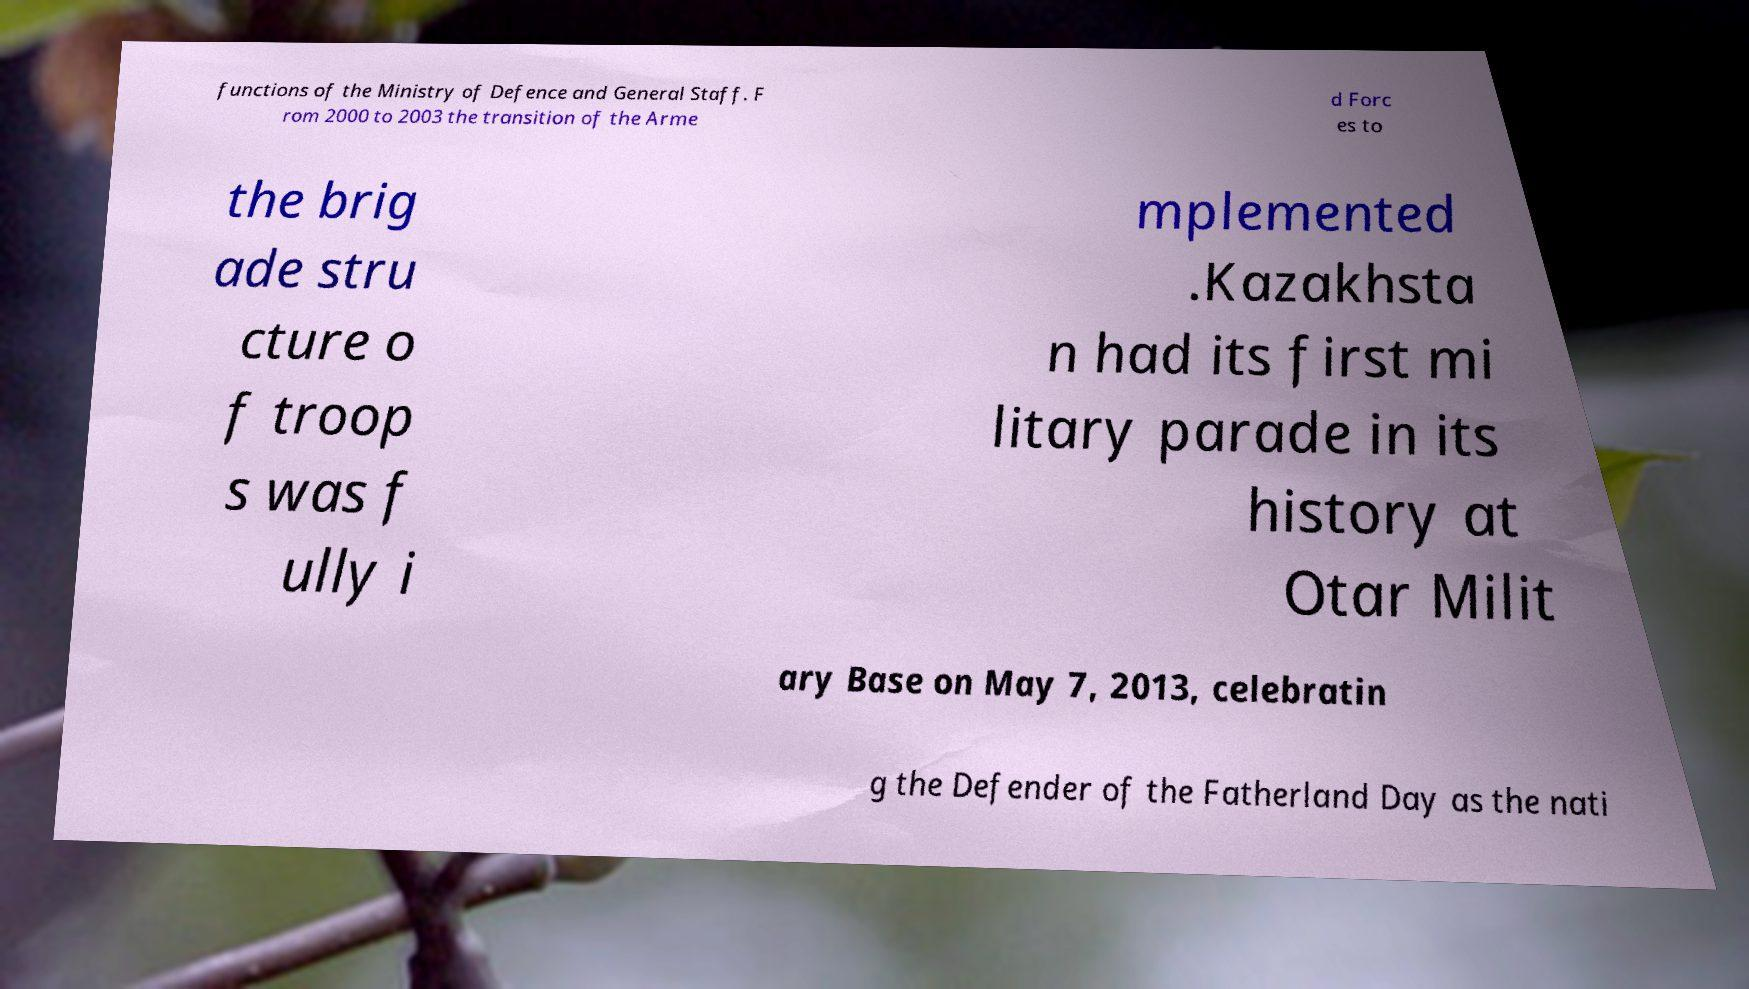Please identify and transcribe the text found in this image. functions of the Ministry of Defence and General Staff. F rom 2000 to 2003 the transition of the Arme d Forc es to the brig ade stru cture o f troop s was f ully i mplemented .Kazakhsta n had its first mi litary parade in its history at Otar Milit ary Base on May 7, 2013, celebratin g the Defender of the Fatherland Day as the nati 